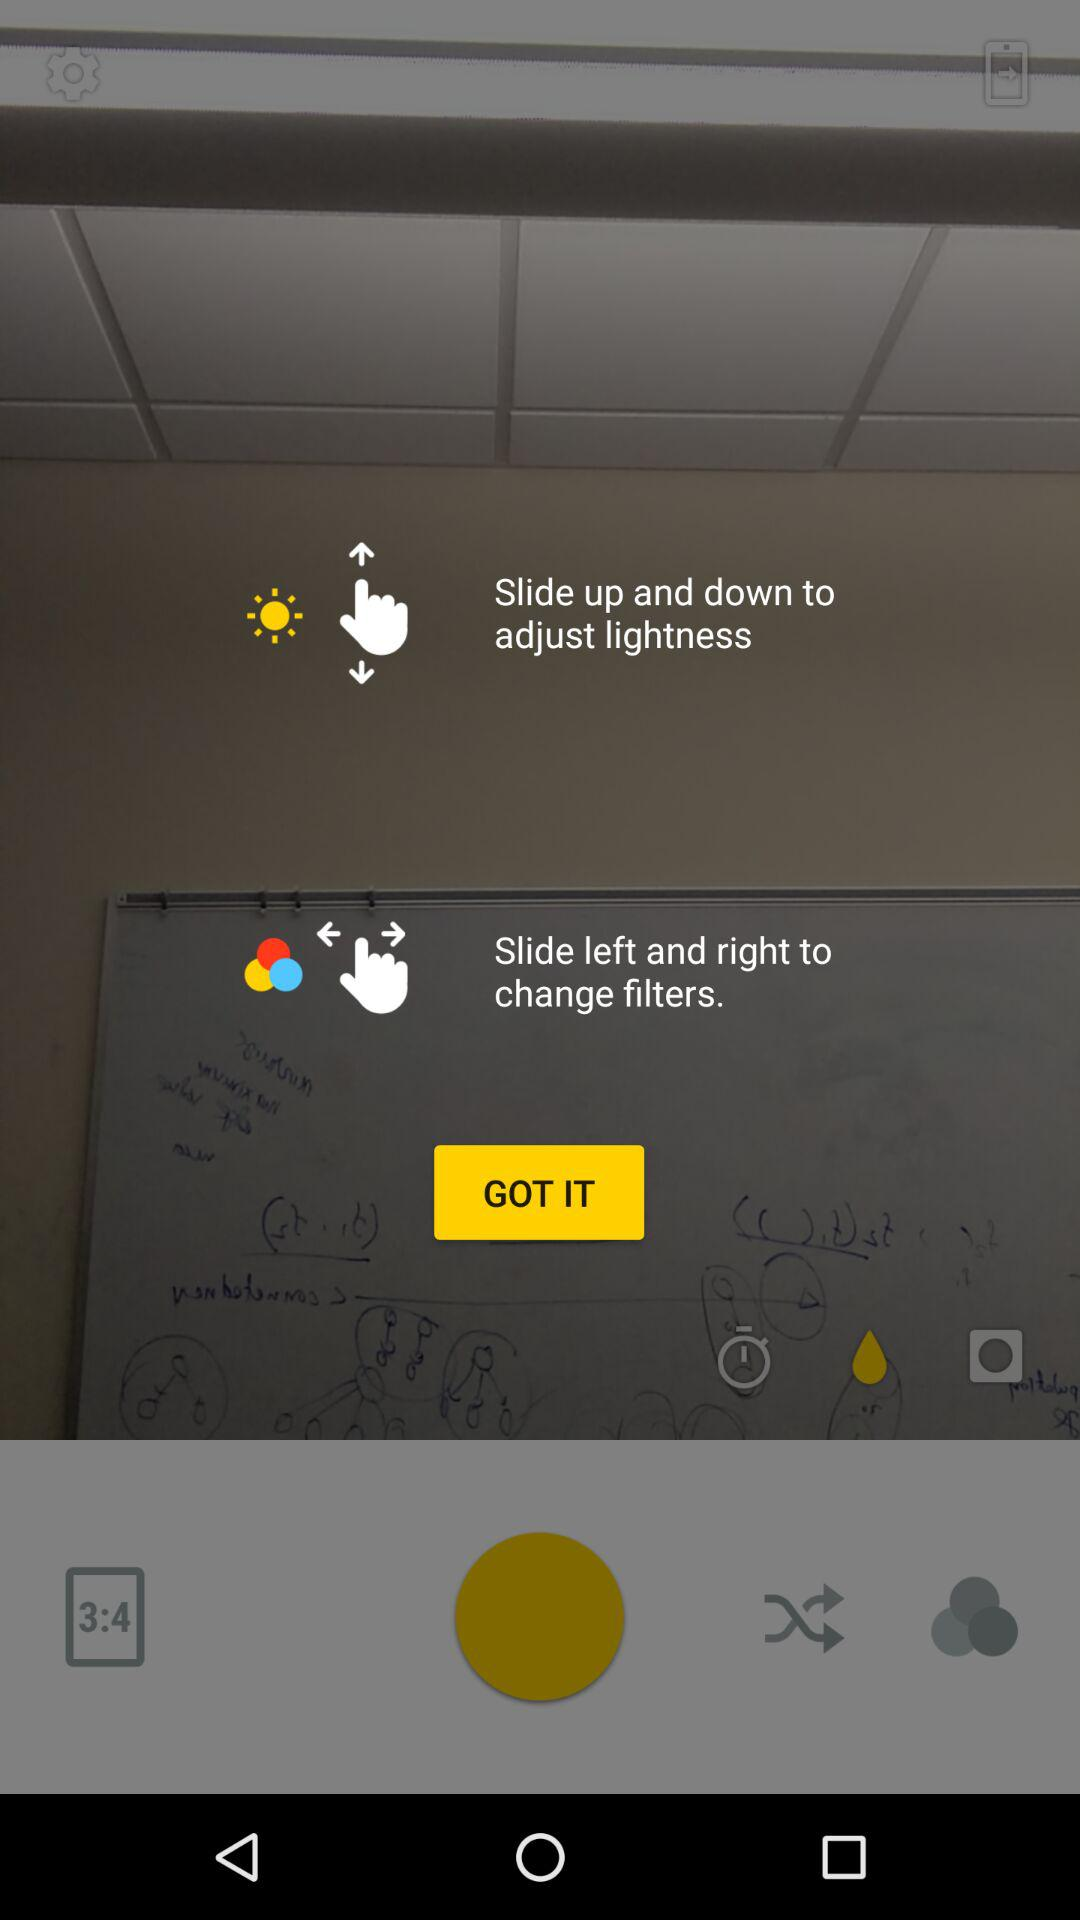What is the ratio of the image? The ratio of the image is 3:4. 